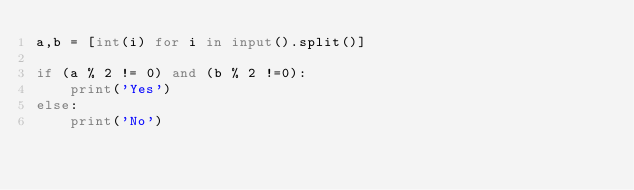Convert code to text. <code><loc_0><loc_0><loc_500><loc_500><_Python_>a,b = [int(i) for i in input().split()]

if (a % 2 != 0) and (b % 2 !=0):
    print('Yes')
else:
    print('No')</code> 